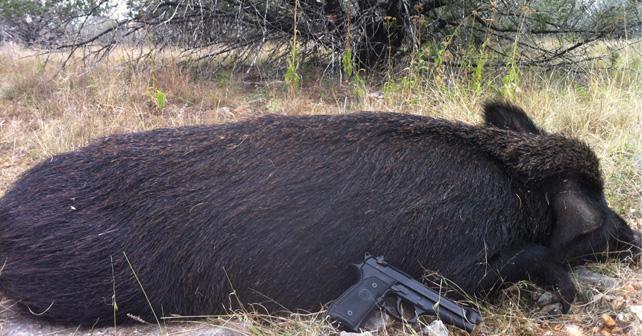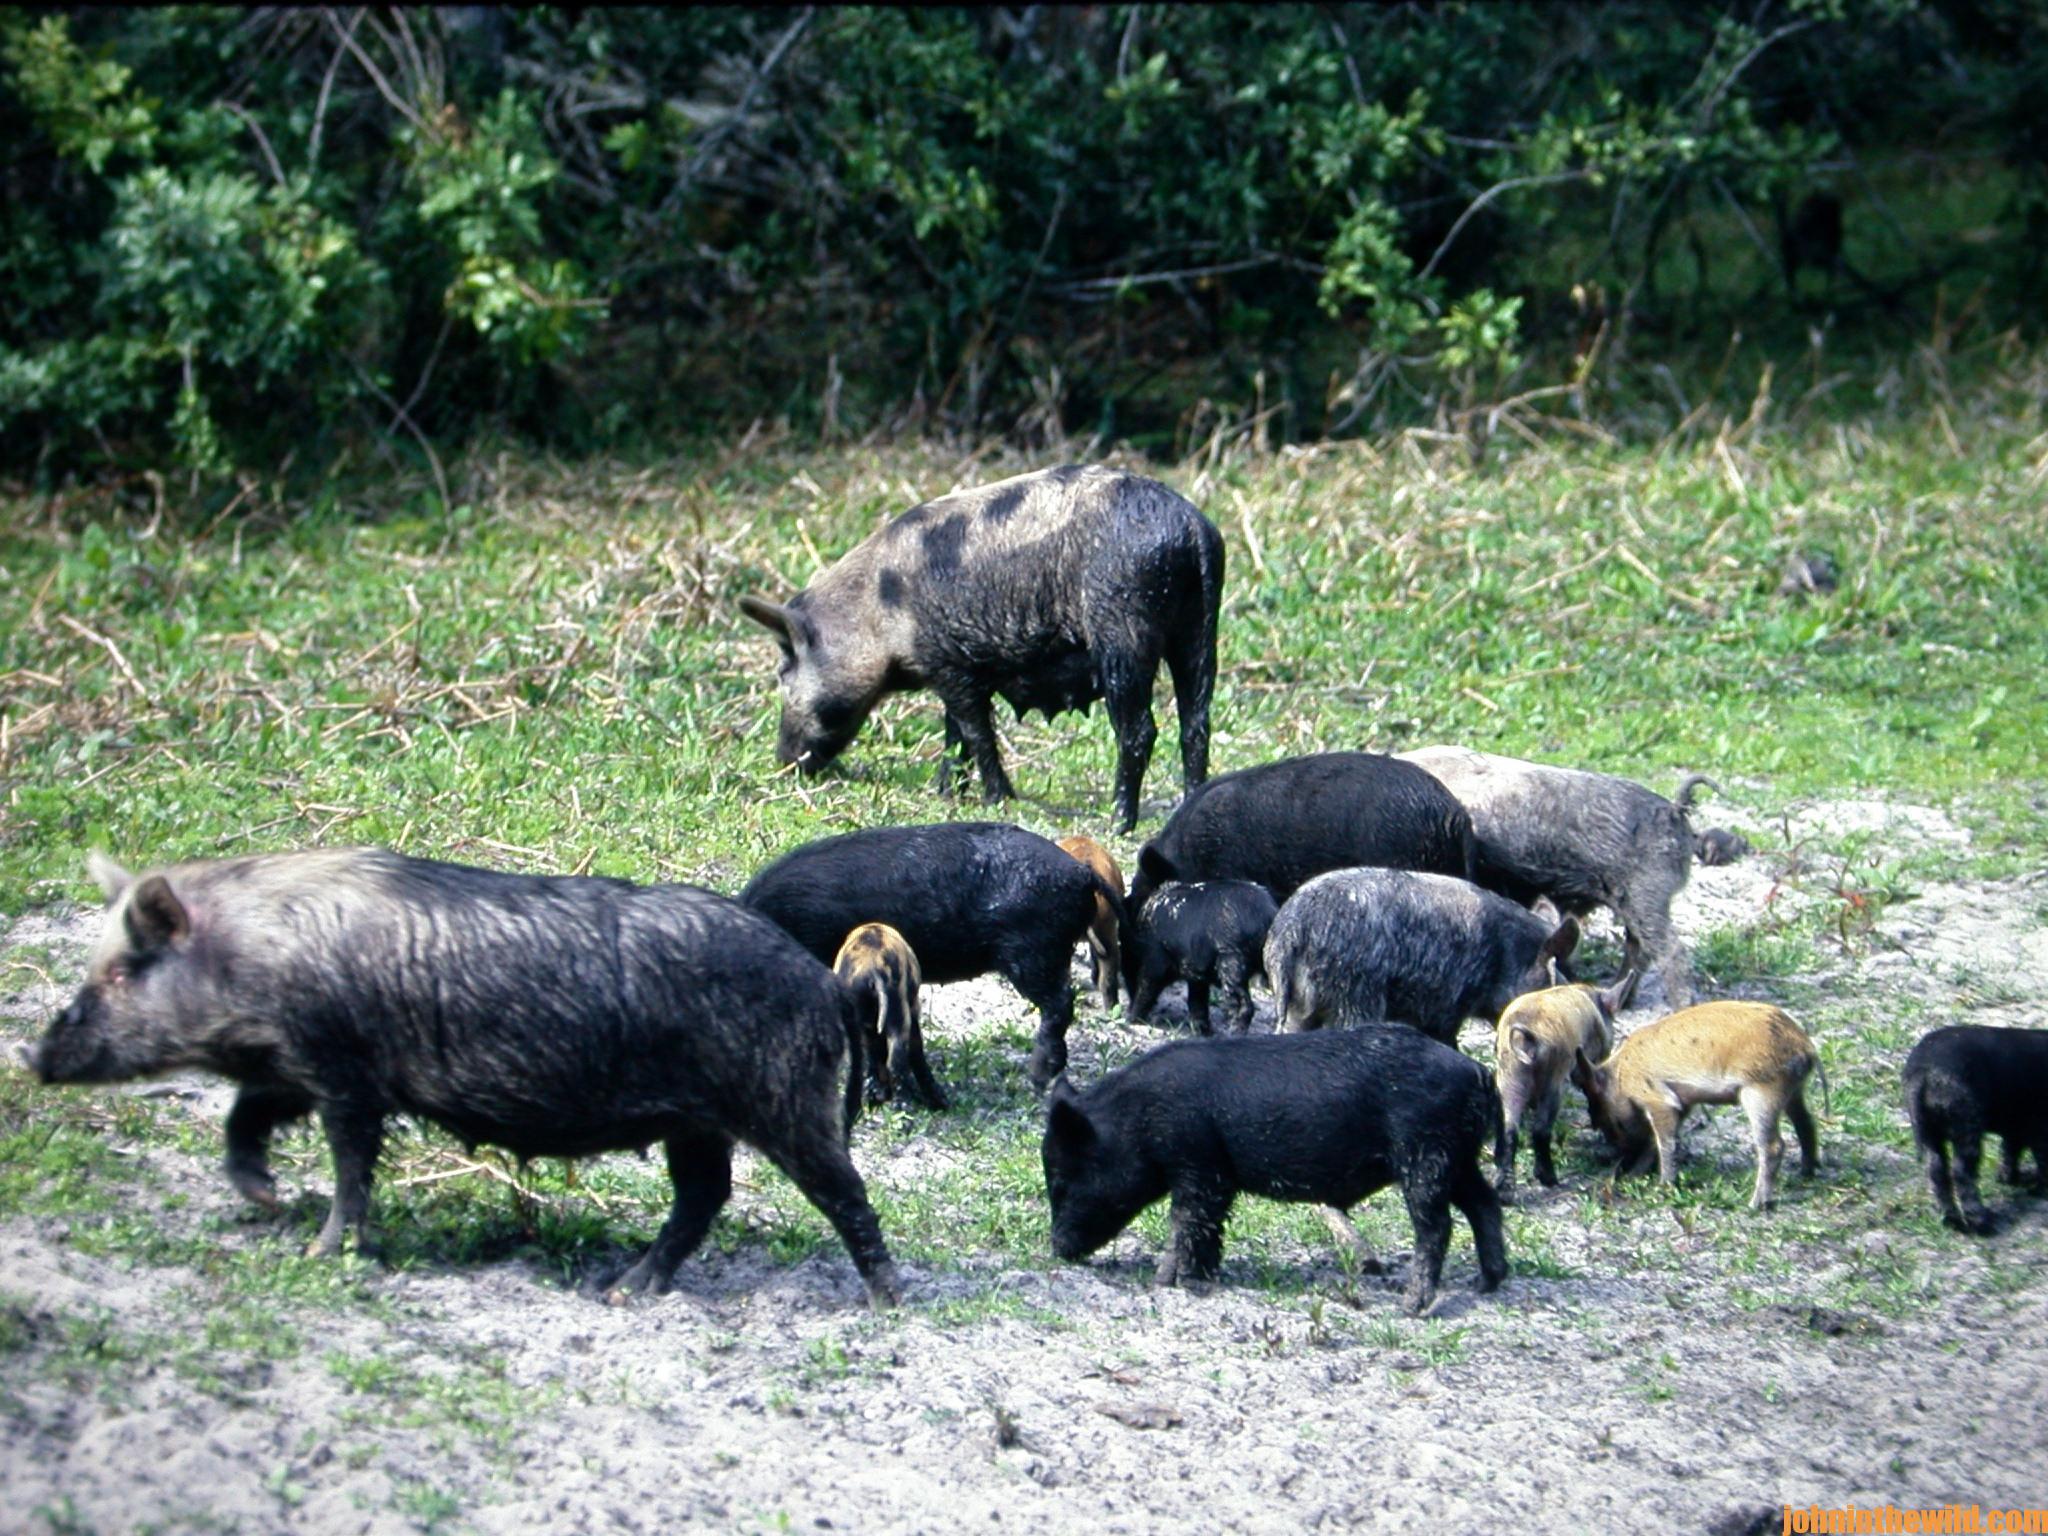The first image is the image on the left, the second image is the image on the right. Examine the images to the left and right. Is the description "there is a person crouched down behind a dead boar on brown grass" accurate? Answer yes or no. No. The first image is the image on the left, the second image is the image on the right. Examine the images to the left and right. Is the description "In at least one image there is a person kneeing over a dead boar with its mouth hanging open." accurate? Answer yes or no. No. 